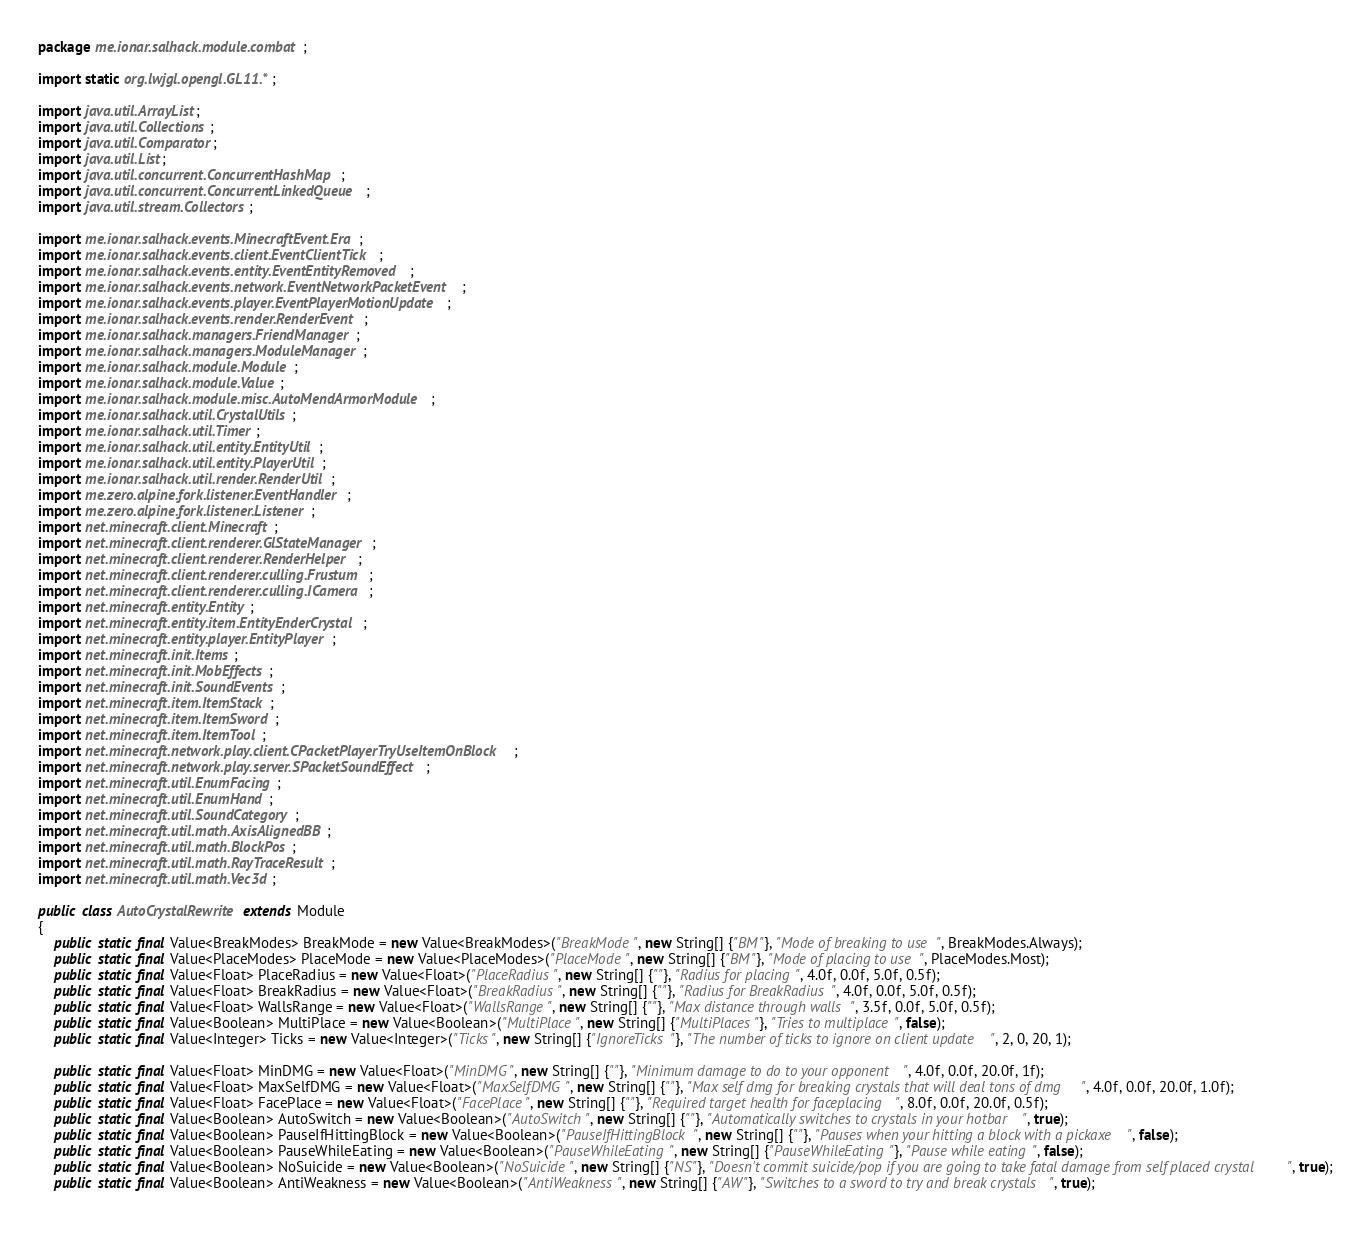Convert code to text. <code><loc_0><loc_0><loc_500><loc_500><_Java_>package me.ionar.salhack.module.combat;

import static org.lwjgl.opengl.GL11.*;

import java.util.ArrayList;
import java.util.Collections;
import java.util.Comparator;
import java.util.List;
import java.util.concurrent.ConcurrentHashMap;
import java.util.concurrent.ConcurrentLinkedQueue;
import java.util.stream.Collectors;

import me.ionar.salhack.events.MinecraftEvent.Era;
import me.ionar.salhack.events.client.EventClientTick;
import me.ionar.salhack.events.entity.EventEntityRemoved;
import me.ionar.salhack.events.network.EventNetworkPacketEvent;
import me.ionar.salhack.events.player.EventPlayerMotionUpdate;
import me.ionar.salhack.events.render.RenderEvent;
import me.ionar.salhack.managers.FriendManager;
import me.ionar.salhack.managers.ModuleManager;
import me.ionar.salhack.module.Module;
import me.ionar.salhack.module.Value;
import me.ionar.salhack.module.misc.AutoMendArmorModule;
import me.ionar.salhack.util.CrystalUtils;
import me.ionar.salhack.util.Timer; 
import me.ionar.salhack.util.entity.EntityUtil;
import me.ionar.salhack.util.entity.PlayerUtil;
import me.ionar.salhack.util.render.RenderUtil;
import me.zero.alpine.fork.listener.EventHandler;
import me.zero.alpine.fork.listener.Listener;
import net.minecraft.client.Minecraft;
import net.minecraft.client.renderer.GlStateManager;
import net.minecraft.client.renderer.RenderHelper;
import net.minecraft.client.renderer.culling.Frustum;
import net.minecraft.client.renderer.culling.ICamera;
import net.minecraft.entity.Entity;
import net.minecraft.entity.item.EntityEnderCrystal;
import net.minecraft.entity.player.EntityPlayer;
import net.minecraft.init.Items;
import net.minecraft.init.MobEffects;
import net.minecraft.init.SoundEvents;
import net.minecraft.item.ItemStack;
import net.minecraft.item.ItemSword;
import net.minecraft.item.ItemTool;
import net.minecraft.network.play.client.CPacketPlayerTryUseItemOnBlock;
import net.minecraft.network.play.server.SPacketSoundEffect;
import net.minecraft.util.EnumFacing;
import net.minecraft.util.EnumHand;
import net.minecraft.util.SoundCategory;
import net.minecraft.util.math.AxisAlignedBB;
import net.minecraft.util.math.BlockPos;
import net.minecraft.util.math.RayTraceResult;
import net.minecraft.util.math.Vec3d;

public class AutoCrystalRewrite extends Module
{
    public static final Value<BreakModes> BreakMode = new Value<BreakModes>("BreakMode", new String[] {"BM"}, "Mode of breaking to use", BreakModes.Always);
    public static final Value<PlaceModes> PlaceMode = new Value<PlaceModes>("PlaceMode", new String[] {"BM"}, "Mode of placing to use", PlaceModes.Most);
    public static final Value<Float> PlaceRadius = new Value<Float>("PlaceRadius", new String[] {""}, "Radius for placing", 4.0f, 0.0f, 5.0f, 0.5f);
    public static final Value<Float> BreakRadius = new Value<Float>("BreakRadius", new String[] {""}, "Radius for BreakRadius", 4.0f, 0.0f, 5.0f, 0.5f);
    public static final Value<Float> WallsRange = new Value<Float>("WallsRange", new String[] {""}, "Max distance through walls", 3.5f, 0.0f, 5.0f, 0.5f);
    public static final Value<Boolean> MultiPlace = new Value<Boolean>("MultiPlace", new String[] {"MultiPlaces"}, "Tries to multiplace", false);
    public static final Value<Integer> Ticks = new Value<Integer>("Ticks", new String[] {"IgnoreTicks"}, "The number of ticks to ignore on client update", 2, 0, 20, 1);
    
    public static final Value<Float> MinDMG = new Value<Float>("MinDMG", new String[] {""}, "Minimum damage to do to your opponent", 4.0f, 0.0f, 20.0f, 1f);
    public static final Value<Float> MaxSelfDMG = new Value<Float>("MaxSelfDMG", new String[] {""}, "Max self dmg for breaking crystals that will deal tons of dmg", 4.0f, 0.0f, 20.0f, 1.0f);
    public static final Value<Float> FacePlace = new Value<Float>("FacePlace", new String[] {""}, "Required target health for faceplacing", 8.0f, 0.0f, 20.0f, 0.5f);
    public static final Value<Boolean> AutoSwitch = new Value<Boolean>("AutoSwitch", new String[] {""}, "Automatically switches to crystals in your hotbar", true);
    public static final Value<Boolean> PauseIfHittingBlock = new Value<Boolean>("PauseIfHittingBlock", new String[] {""}, "Pauses when your hitting a block with a pickaxe", false);
    public static final Value<Boolean> PauseWhileEating = new Value<Boolean>("PauseWhileEating", new String[] {"PauseWhileEating"}, "Pause while eating", false);
    public static final Value<Boolean> NoSuicide = new Value<Boolean>("NoSuicide", new String[] {"NS"}, "Doesn't commit suicide/pop if you are going to take fatal damage from self placed crystal", true);
    public static final Value<Boolean> AntiWeakness = new Value<Boolean>("AntiWeakness", new String[] {"AW"}, "Switches to a sword to try and break crystals", true);
    </code> 